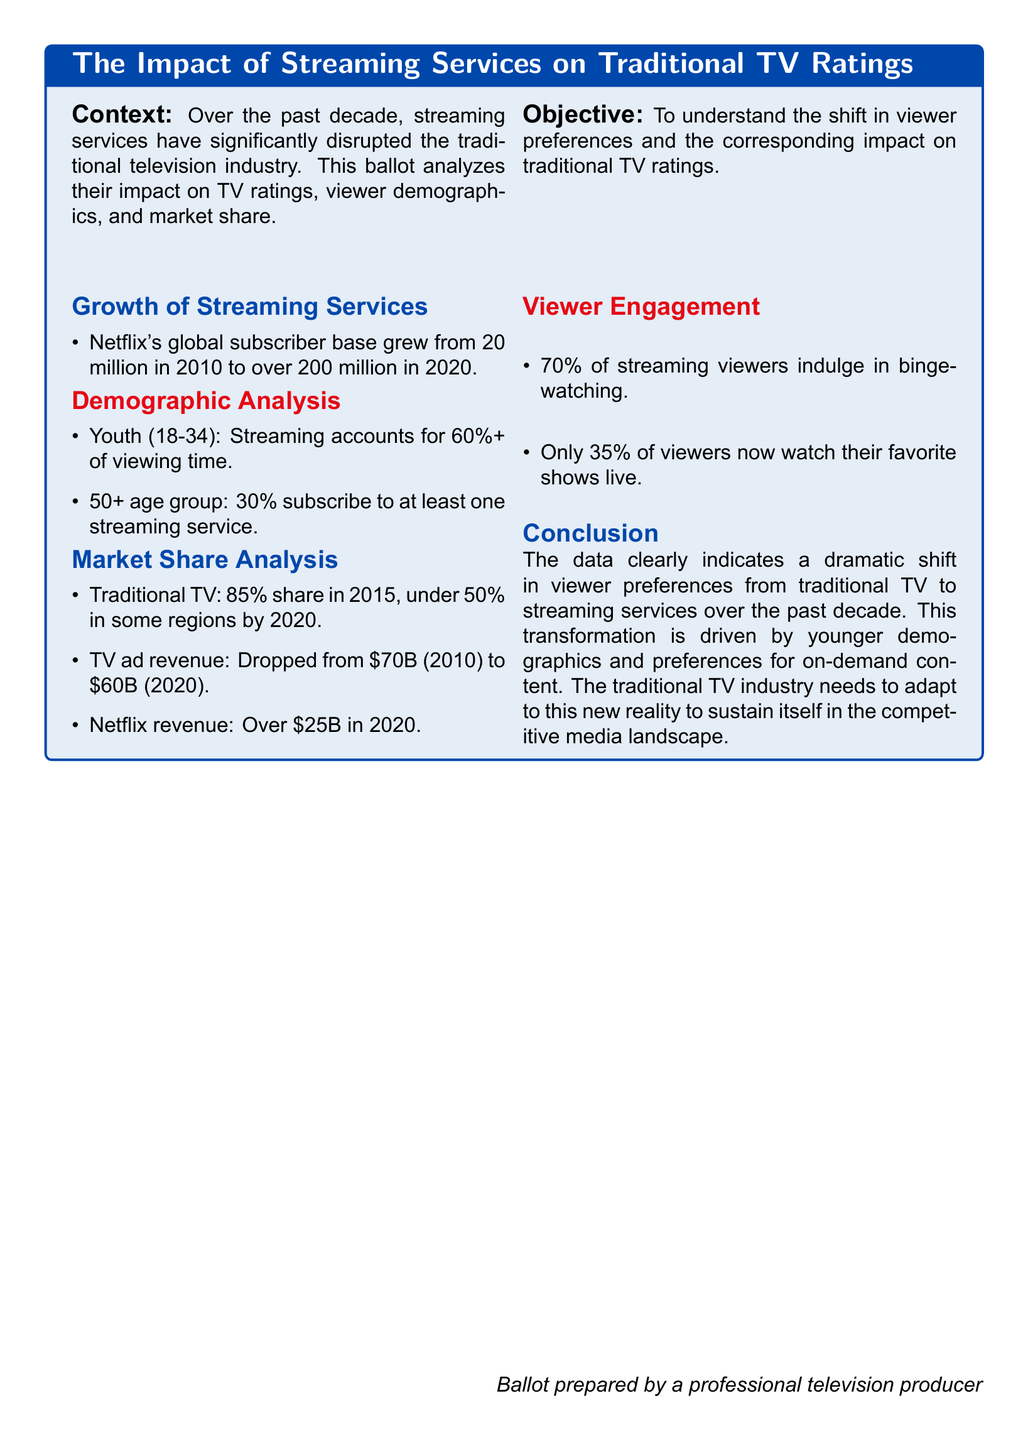What was Netflix's global subscriber count in 2010? The document states that Netflix's global subscriber base grew from 20 million in 2010, confirming the count as 20 million.
Answer: 20 million What percentage of the youth demographic (18-34) prefers streaming? The document indicates that streaming accounts for 60%+ of viewing time among the youth demographic.
Answer: 60%+ What was the traditional TV market share in 2015? The document mentions that traditional TV held an 85% share in 2015.
Answer: 85% What is the percentage of the 50+ age group that subscribes to at least one streaming service? The document states that 30% of the 50+ age group subscribe to at least one streaming service.
Answer: 30% What is the decline in TV ad revenue from 2010 to 2020? The document indicates that TV ad revenue dropped from $70B in 2010 to $60B in 2020, which shows a decline of $10B.
Answer: $10B What percentage of streaming viewers participate in binge-watching? The document reveals that 70% of streaming viewers indulge in binge-watching.
Answer: 70% What was Netflix's revenue in 2020? The document states that Netflix revenue was over $25B in 2020.
Answer: Over $25B What percentage of viewers watch their favorite shows live now? According to the document, only 35% of viewers currently watch their favorite shows live.
Answer: 35% What two groups does the demographic analysis focus on? The document specifies the groups as Youth (18-34) and 50+ age group.
Answer: Youth (18-34), 50+ age group 